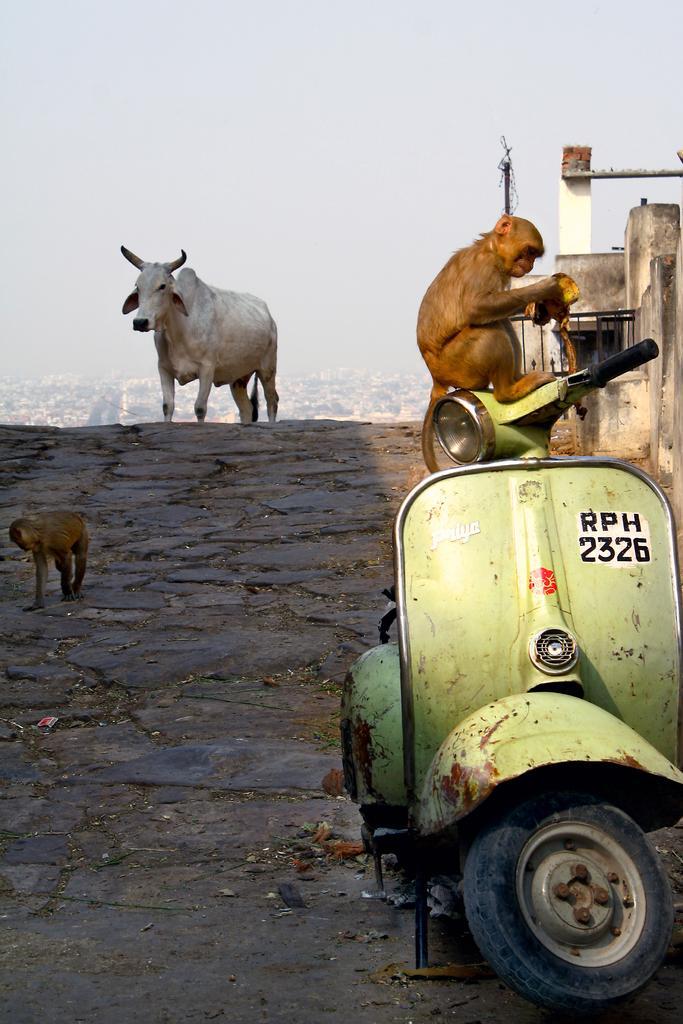How would you summarize this image in a sentence or two? In the image we can see there are animals and the two wheeler. Here we can see footpath, wall, pole and the sky. 